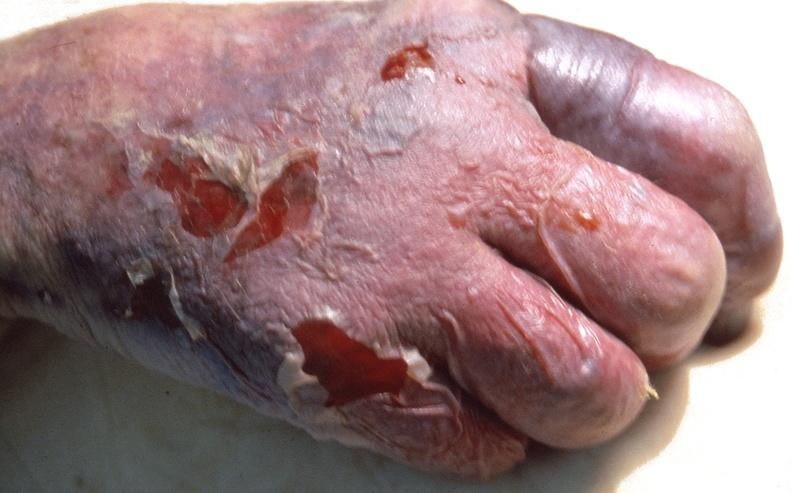what does this image show?
Answer the question using a single word or phrase. Skin ulceration and necrosis 